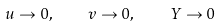Convert formula to latex. <formula><loc_0><loc_0><loc_500><loc_500>u \rightarrow 0 , \quad v \rightarrow 0 , \quad Y \rightarrow 0</formula> 